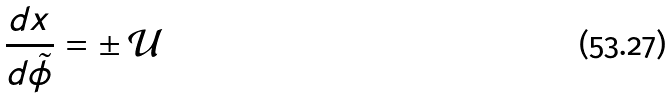Convert formula to latex. <formula><loc_0><loc_0><loc_500><loc_500>\frac { d x } { d \tilde { \phi } } = \pm \, \mathcal { U }</formula> 